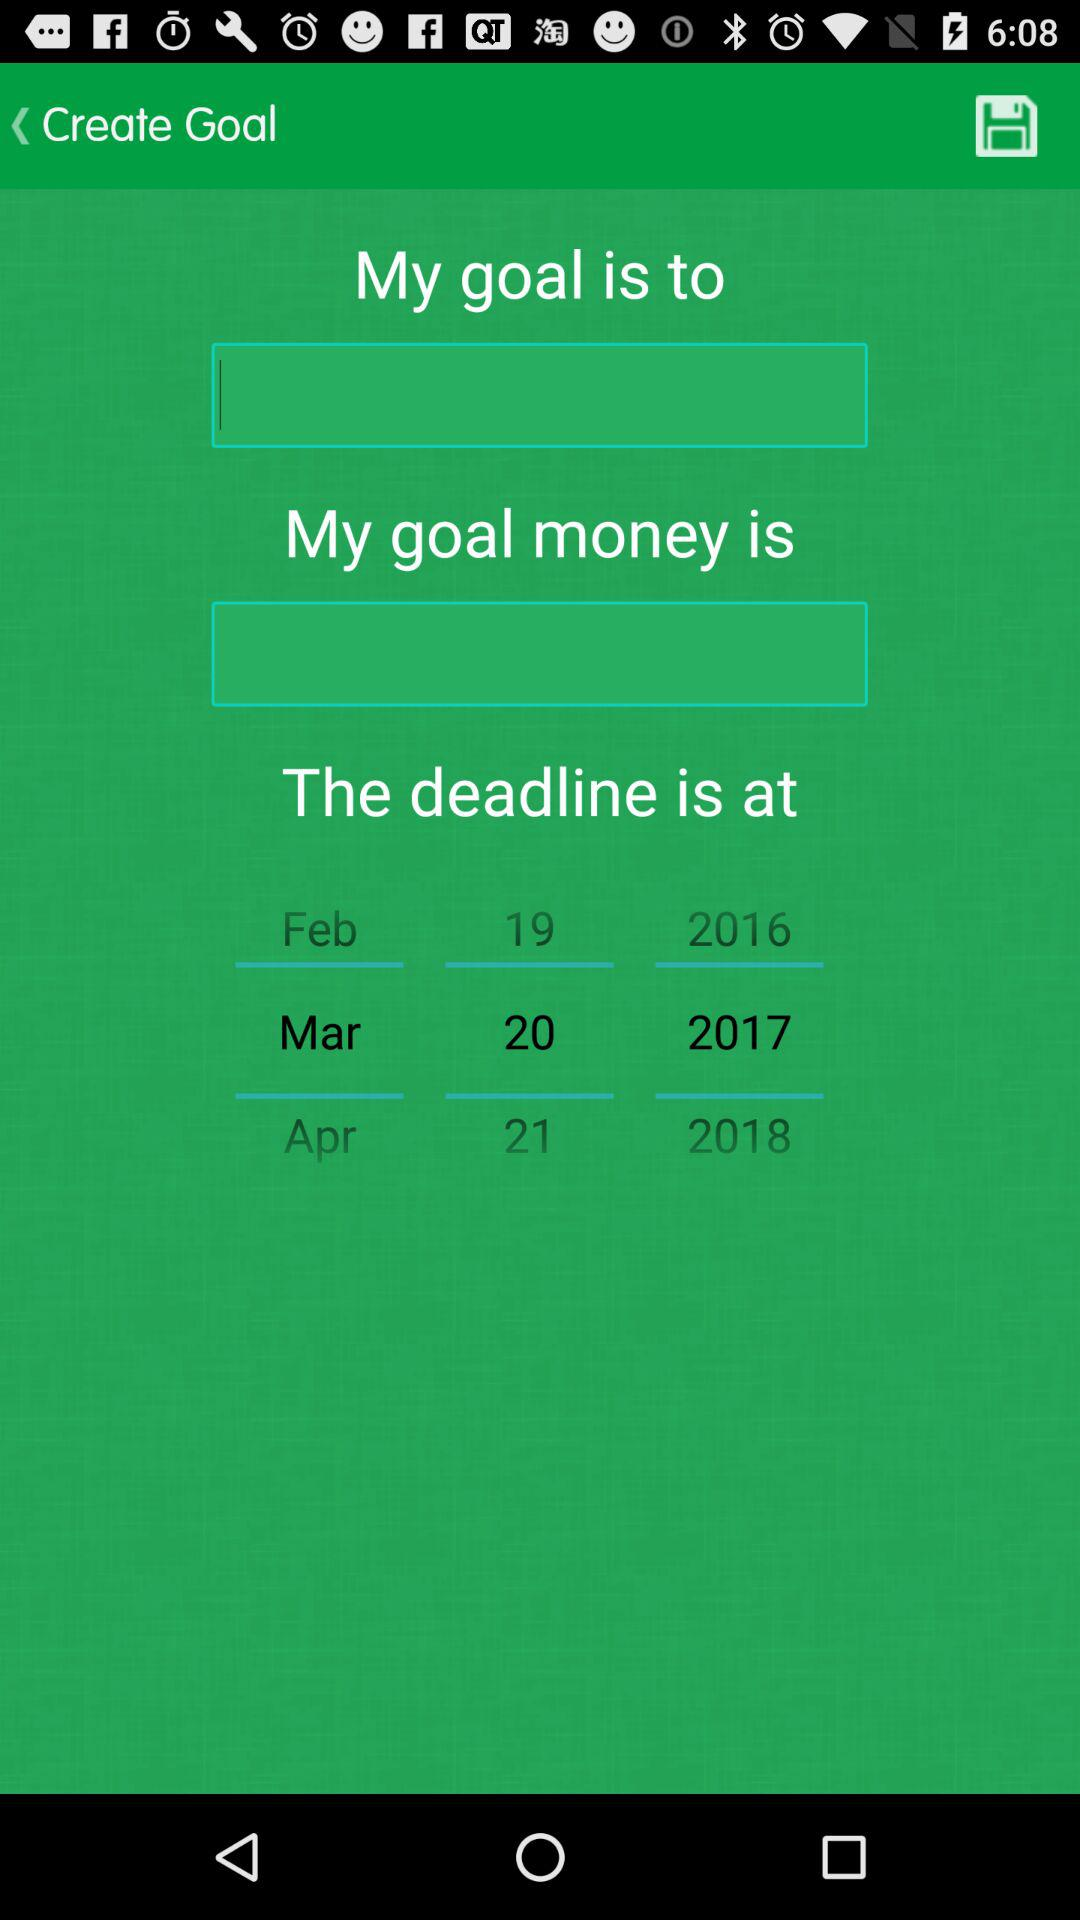Which months are shown on the screen? The shown months are February, March and April. 